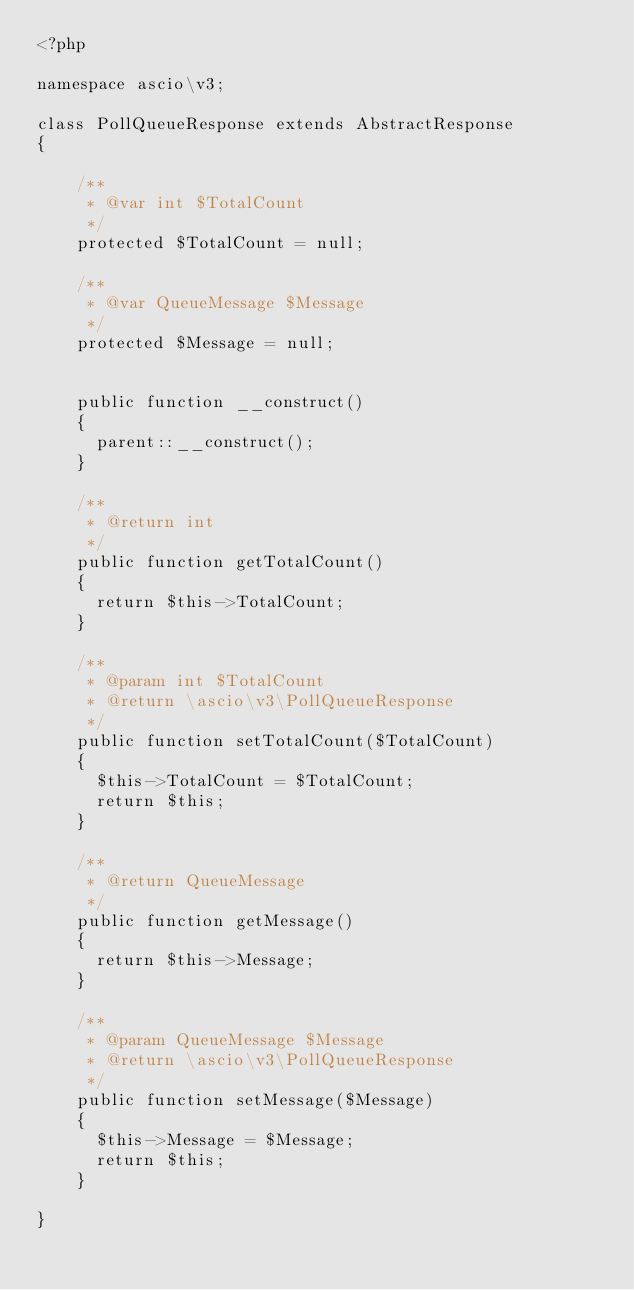<code> <loc_0><loc_0><loc_500><loc_500><_PHP_><?php

namespace ascio\v3;

class PollQueueResponse extends AbstractResponse
{

    /**
     * @var int $TotalCount
     */
    protected $TotalCount = null;

    /**
     * @var QueueMessage $Message
     */
    protected $Message = null;

    
    public function __construct()
    {
      parent::__construct();
    }

    /**
     * @return int
     */
    public function getTotalCount()
    {
      return $this->TotalCount;
    }

    /**
     * @param int $TotalCount
     * @return \ascio\v3\PollQueueResponse
     */
    public function setTotalCount($TotalCount)
    {
      $this->TotalCount = $TotalCount;
      return $this;
    }

    /**
     * @return QueueMessage
     */
    public function getMessage()
    {
      return $this->Message;
    }

    /**
     * @param QueueMessage $Message
     * @return \ascio\v3\PollQueueResponse
     */
    public function setMessage($Message)
    {
      $this->Message = $Message;
      return $this;
    }

}
</code> 